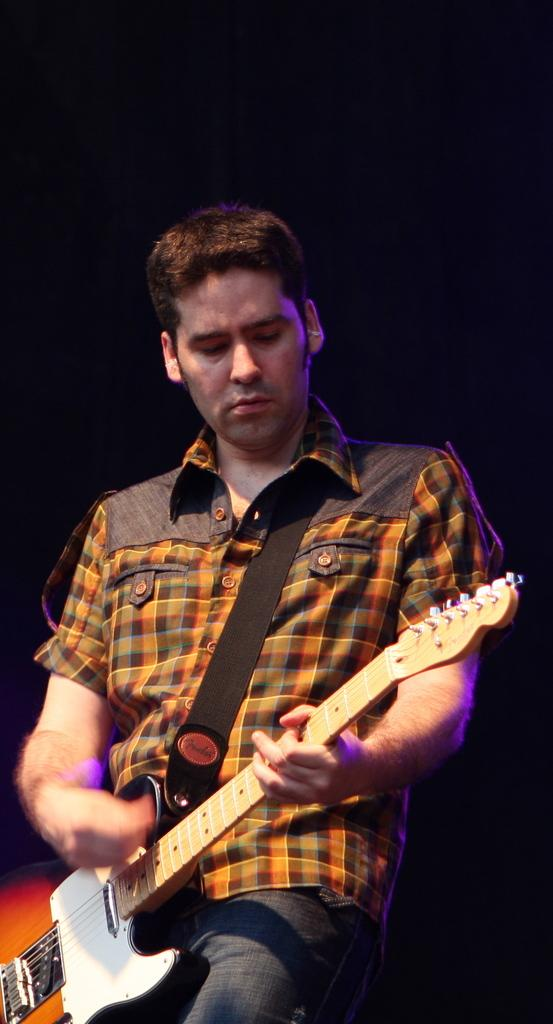What is the main subject of the image? The main subject of the image is a man. What is the man doing in the image? The man is sitting and playing a guitar. Can you see any ocean, bomb, or bushes in the image? No, there is no ocean, bomb, or bushes present in the image. 